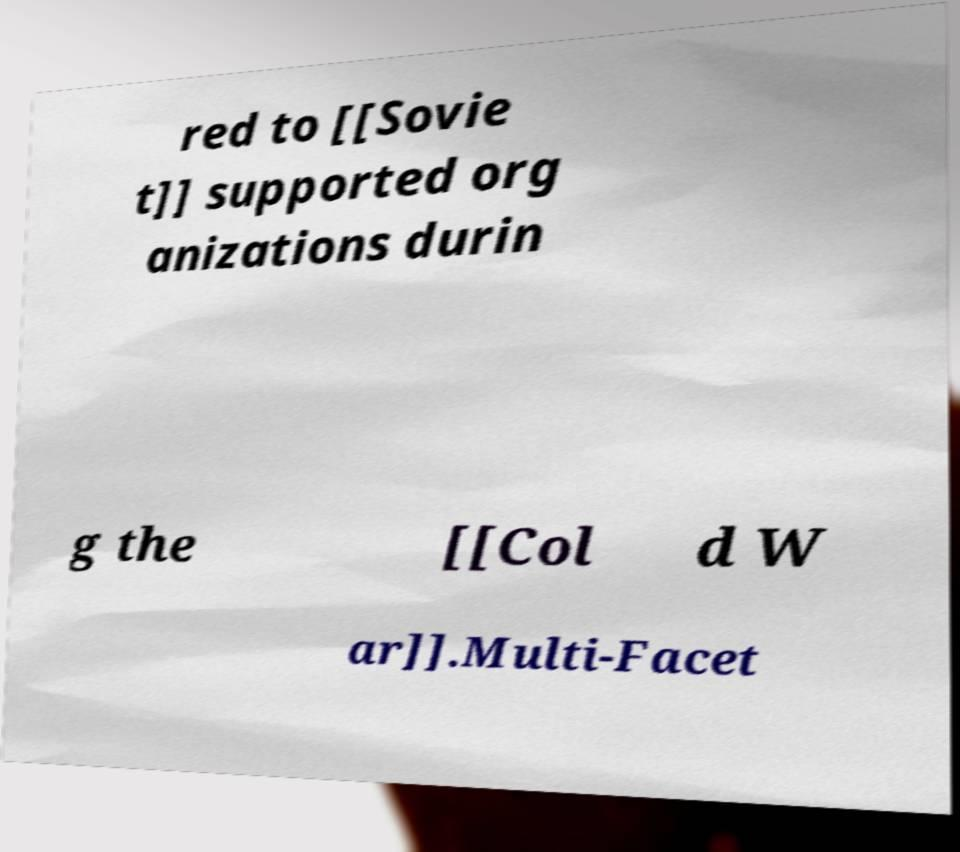Please identify and transcribe the text found in this image. red to [[Sovie t]] supported org anizations durin g the [[Col d W ar]].Multi-Facet 